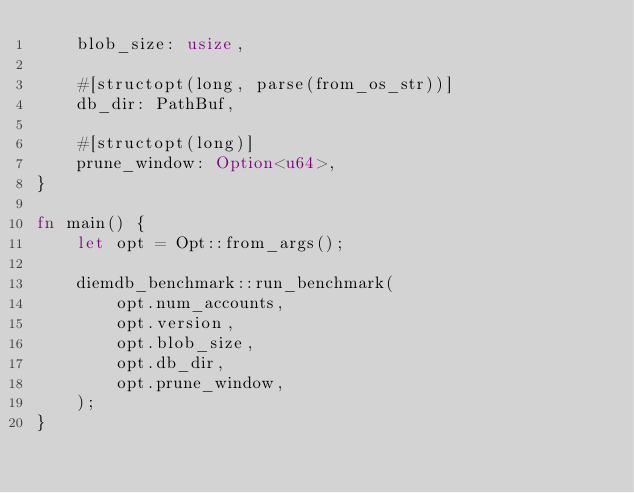<code> <loc_0><loc_0><loc_500><loc_500><_Rust_>    blob_size: usize,

    #[structopt(long, parse(from_os_str))]
    db_dir: PathBuf,

    #[structopt(long)]
    prune_window: Option<u64>,
}

fn main() {
    let opt = Opt::from_args();

    diemdb_benchmark::run_benchmark(
        opt.num_accounts,
        opt.version,
        opt.blob_size,
        opt.db_dir,
        opt.prune_window,
    );
}
</code> 